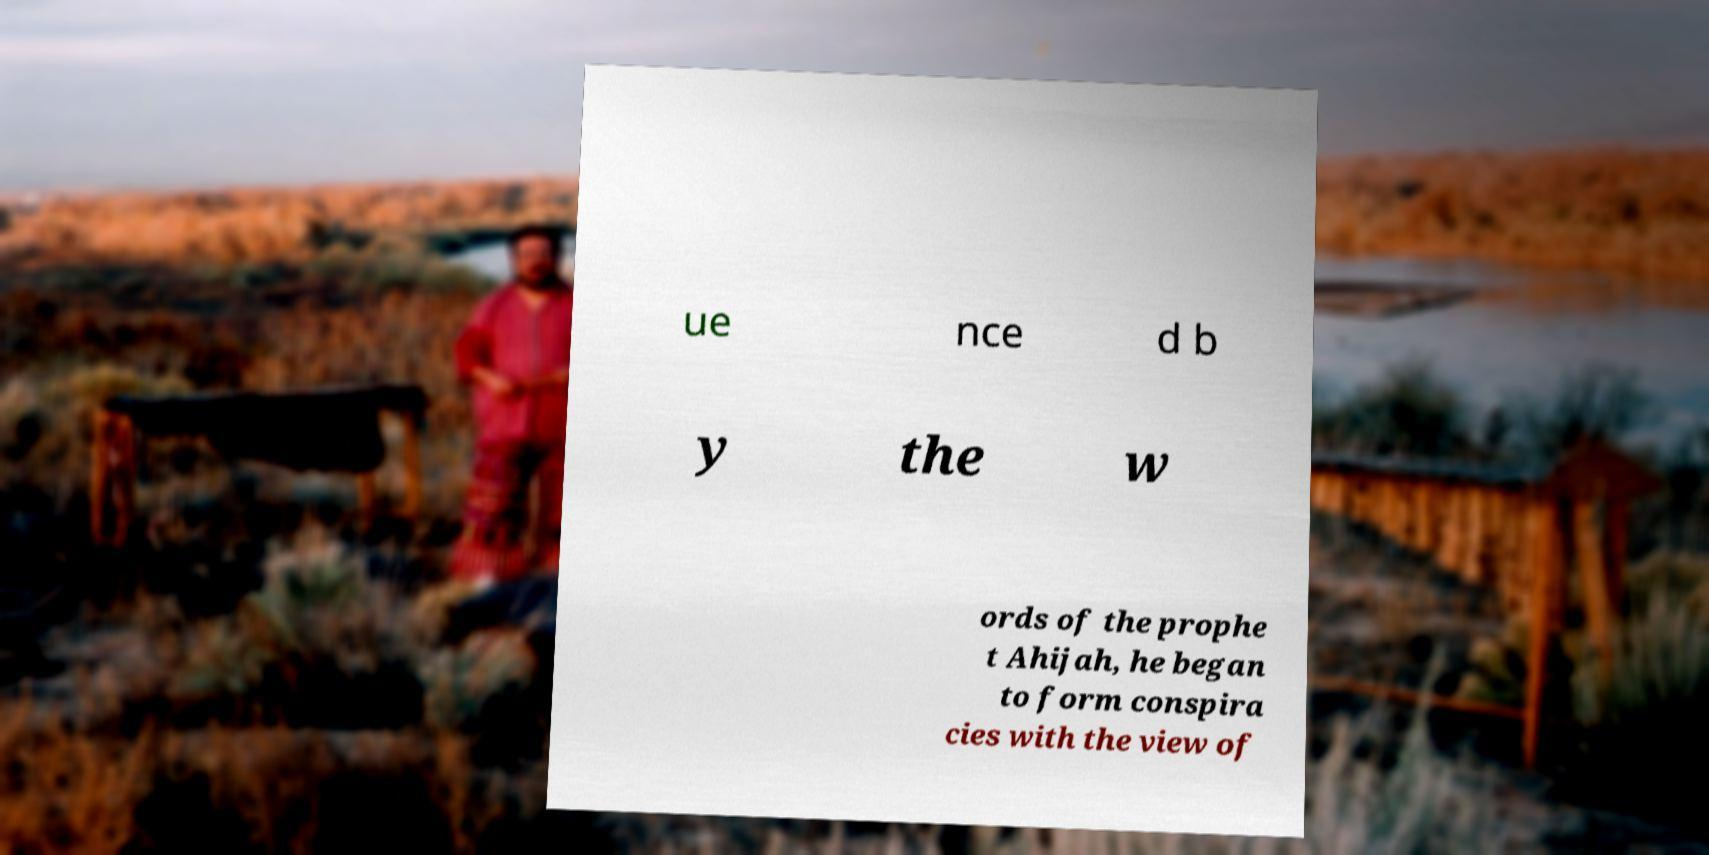Could you assist in decoding the text presented in this image and type it out clearly? ue nce d b y the w ords of the prophe t Ahijah, he began to form conspira cies with the view of 